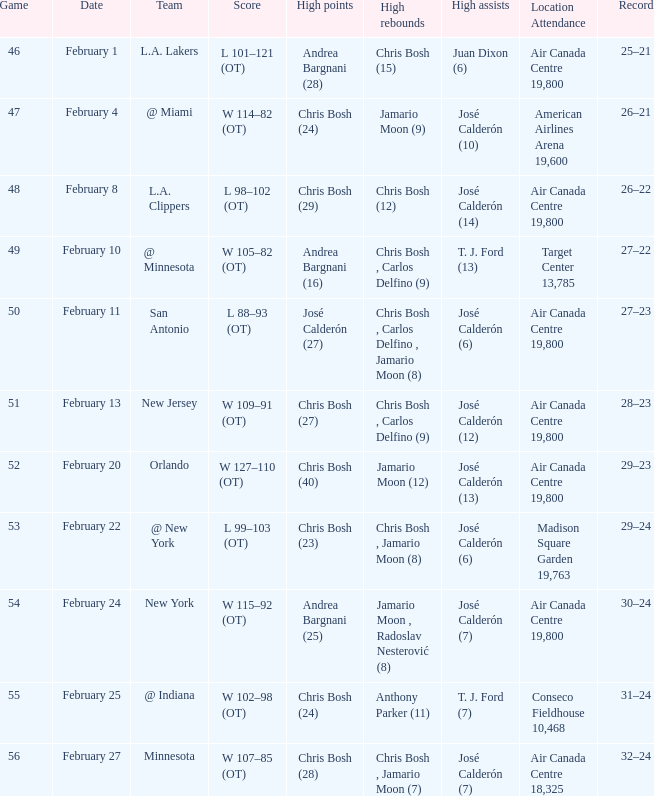Who scored the most points in Game 49? Andrea Bargnani (16). 